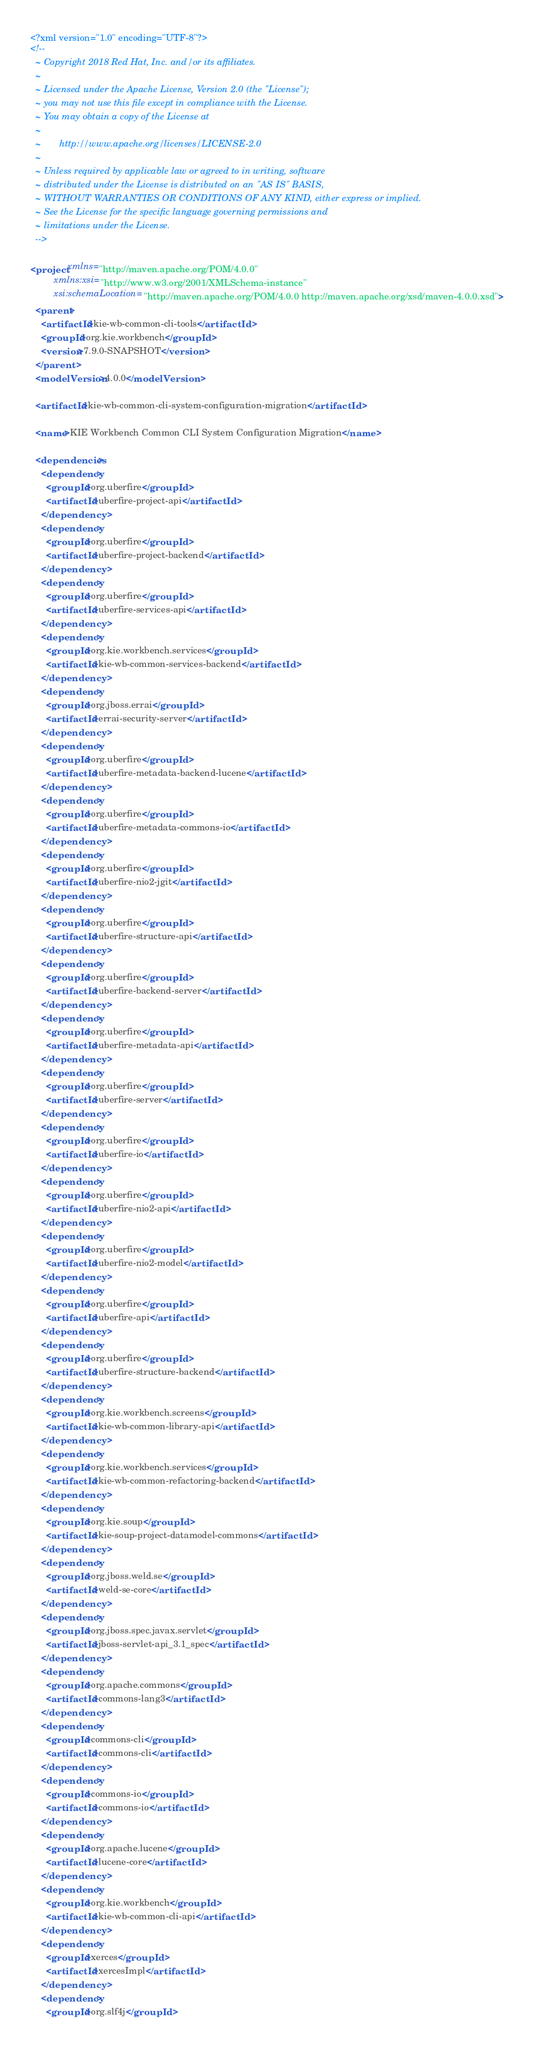<code> <loc_0><loc_0><loc_500><loc_500><_XML_><?xml version="1.0" encoding="UTF-8"?>
<!--
  ~ Copyright 2018 Red Hat, Inc. and/or its affiliates.
  ~
  ~ Licensed under the Apache License, Version 2.0 (the "License");
  ~ you may not use this file except in compliance with the License.
  ~ You may obtain a copy of the License at
  ~
  ~       http://www.apache.org/licenses/LICENSE-2.0
  ~
  ~ Unless required by applicable law or agreed to in writing, software
  ~ distributed under the License is distributed on an "AS IS" BASIS,
  ~ WITHOUT WARRANTIES OR CONDITIONS OF ANY KIND, either express or implied.
  ~ See the License for the specific language governing permissions and
  ~ limitations under the License.
  -->

<project xmlns="http://maven.apache.org/POM/4.0.0"
         xmlns:xsi="http://www.w3.org/2001/XMLSchema-instance"
         xsi:schemaLocation="http://maven.apache.org/POM/4.0.0 http://maven.apache.org/xsd/maven-4.0.0.xsd">
  <parent>
    <artifactId>kie-wb-common-cli-tools</artifactId>
    <groupId>org.kie.workbench</groupId>
    <version>7.9.0-SNAPSHOT</version>
  </parent>
  <modelVersion>4.0.0</modelVersion>

  <artifactId>kie-wb-common-cli-system-configuration-migration</artifactId>

  <name>KIE Workbench Common CLI System Configuration Migration</name>

  <dependencies>
    <dependency>
      <groupId>org.uberfire</groupId>
      <artifactId>uberfire-project-api</artifactId>
    </dependency>
    <dependency>
      <groupId>org.uberfire</groupId>
      <artifactId>uberfire-project-backend</artifactId>
    </dependency>
    <dependency>
      <groupId>org.uberfire</groupId>
      <artifactId>uberfire-services-api</artifactId>
    </dependency>
    <dependency>
      <groupId>org.kie.workbench.services</groupId>
      <artifactId>kie-wb-common-services-backend</artifactId>
    </dependency>
    <dependency>
      <groupId>org.jboss.errai</groupId>
      <artifactId>errai-security-server</artifactId>
    </dependency>
    <dependency>
      <groupId>org.uberfire</groupId>
      <artifactId>uberfire-metadata-backend-lucene</artifactId>
    </dependency>
    <dependency>
      <groupId>org.uberfire</groupId>
      <artifactId>uberfire-metadata-commons-io</artifactId>
    </dependency>
    <dependency>
      <groupId>org.uberfire</groupId>
      <artifactId>uberfire-nio2-jgit</artifactId>
    </dependency>
    <dependency>
      <groupId>org.uberfire</groupId>
      <artifactId>uberfire-structure-api</artifactId>
    </dependency>
    <dependency>
      <groupId>org.uberfire</groupId>
      <artifactId>uberfire-backend-server</artifactId>
    </dependency>
    <dependency>
      <groupId>org.uberfire</groupId>
      <artifactId>uberfire-metadata-api</artifactId>
    </dependency>
    <dependency>
      <groupId>org.uberfire</groupId>
      <artifactId>uberfire-server</artifactId>
    </dependency>
    <dependency>
      <groupId>org.uberfire</groupId>
      <artifactId>uberfire-io</artifactId>
    </dependency>
    <dependency>
      <groupId>org.uberfire</groupId>
      <artifactId>uberfire-nio2-api</artifactId>
    </dependency>
    <dependency>
      <groupId>org.uberfire</groupId>
      <artifactId>uberfire-nio2-model</artifactId>
    </dependency>
    <dependency>
      <groupId>org.uberfire</groupId>
      <artifactId>uberfire-api</artifactId>
    </dependency>
    <dependency>
      <groupId>org.uberfire</groupId>
      <artifactId>uberfire-structure-backend</artifactId>
    </dependency>
    <dependency>
      <groupId>org.kie.workbench.screens</groupId>
      <artifactId>kie-wb-common-library-api</artifactId>
    </dependency>
    <dependency>
      <groupId>org.kie.workbench.services</groupId>
      <artifactId>kie-wb-common-refactoring-backend</artifactId>
    </dependency>
    <dependency>
      <groupId>org.kie.soup</groupId>
      <artifactId>kie-soup-project-datamodel-commons</artifactId>
    </dependency>
    <dependency>
      <groupId>org.jboss.weld.se</groupId>
      <artifactId>weld-se-core</artifactId>
    </dependency>
    <dependency>
      <groupId>org.jboss.spec.javax.servlet</groupId>
      <artifactId>jboss-servlet-api_3.1_spec</artifactId>
    </dependency>
    <dependency>
      <groupId>org.apache.commons</groupId>
      <artifactId>commons-lang3</artifactId>
    </dependency>
    <dependency>
      <groupId>commons-cli</groupId>
      <artifactId>commons-cli</artifactId>
    </dependency>
    <dependency>
      <groupId>commons-io</groupId>
      <artifactId>commons-io</artifactId>
    </dependency>
    <dependency>
      <groupId>org.apache.lucene</groupId>
      <artifactId>lucene-core</artifactId>
    </dependency>
    <dependency>
      <groupId>org.kie.workbench</groupId>
      <artifactId>kie-wb-common-cli-api</artifactId>
    </dependency>
    <dependency>
      <groupId>xerces</groupId>
      <artifactId>xercesImpl</artifactId>
    </dependency>
    <dependency>
      <groupId>org.slf4j</groupId></code> 